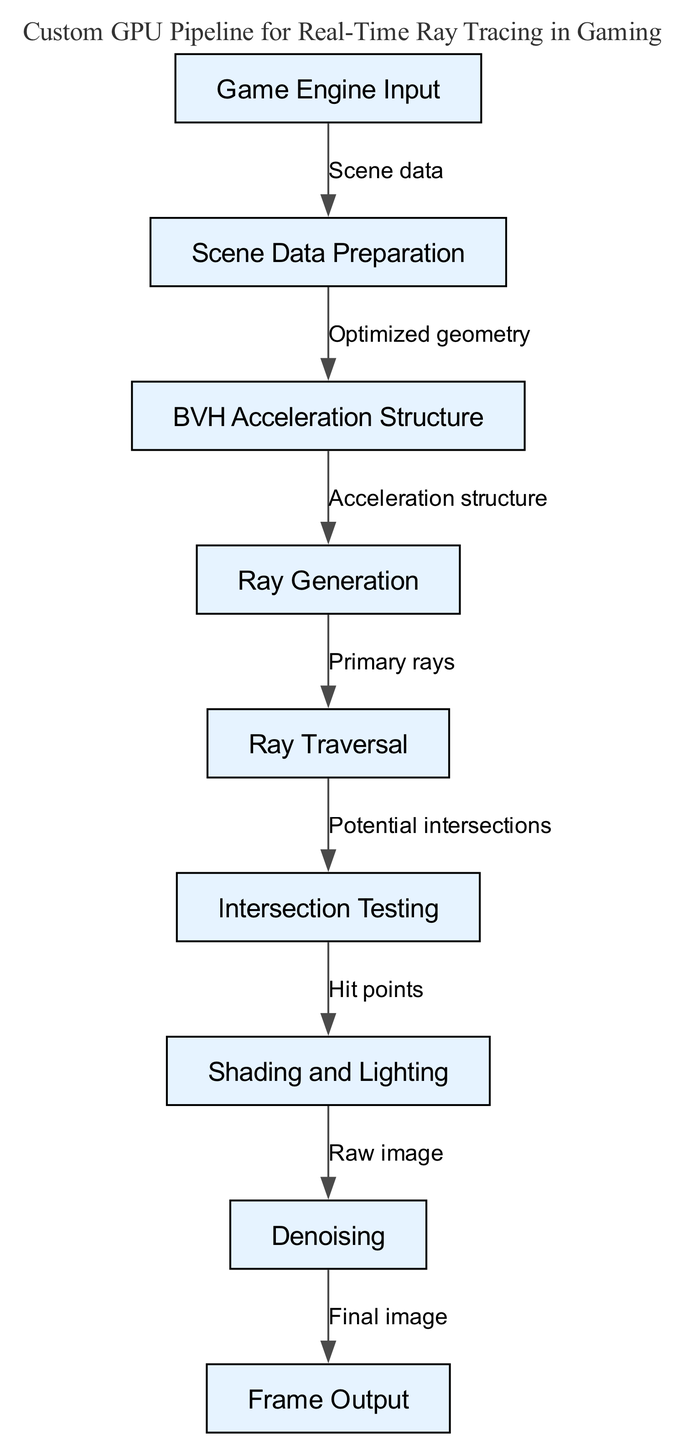What is the starting point of the GPU pipeline? The diagram indicates that the initial step in the GPU pipeline is the "Game Engine Input." This node serves as the origin from which the process begins, as it receives the necessary scene data for further steps.
Answer: Game Engine Input How many nodes are present in the diagram? By counting the distinct nodes listed in the diagram, we find there are nine unique components, each representing a specific step or function in the custom GPU pipeline for ray tracing.
Answer: 9 What follows after "Scene Data Preparation"? According to the flow in the diagram, "Scene Data Preparation" leads directly to "BVH Acceleration Structure." This represents the sequence where prepared scene data is used to create an acceleration structure for efficient ray tracing.
Answer: BVH Acceleration Structure What is the final process in the pipeline? The diagram clearly shows that "Frame Output" is the last node in the flow, receiving data after denoising has been completed, indicating the last stage of rendering the final image.
Answer: Frame Output Which node is connected to both "Shading and Lighting" and "Denoising"? The diagram depicts that "Shading and Lighting" connects to "Denoising." This connection illustrates that once shading and lighting calculations are performed, the resulting image undergoes denoising to enhance visual quality.
Answer: Shading and Lighting What are the intermediate steps between "Ray Generation" and "Frame Output"? The sequence illustrates that after "Ray Generation," the process moves to "Ray Traversal," then "Intersection Testing," followed by "Shading and Lighting," and finally "Denoising," culminating in "Frame Output." By tracing these steps, we can determine the necessary processes for producing the final output.
Answer: Ray Traversal, Intersection Testing, Shading and Lighting, Denoising How does "Intersection Testing" relate to "Shading and Lighting"? The diagram indicates that "Intersection Testing" provides "Hit points," which are essential for "Shading and Lighting" to determine how light interacts with those points, thus establishing a direct functional relationship between these two nodes.
Answer: Hit points Which node serves as the input to the "Ray Traversal"? Upon reviewing the flowchart, it becomes apparent that "Ray Generation" directly feeds into "Ray Traversal," indicating it is the critical input for the subsequent step of traversing rays through the scene geometry.
Answer: Ray Generation What kind of structure does "BVH Acceleration Structure" represent? The diagram refers to it as an "Acceleration structure," which is specifically designed to optimize the ray tracing process by allowing quicker calculations of which objects a given ray might intersect with in the scene, fundamentally enhancing performance.
Answer: Acceleration structure 